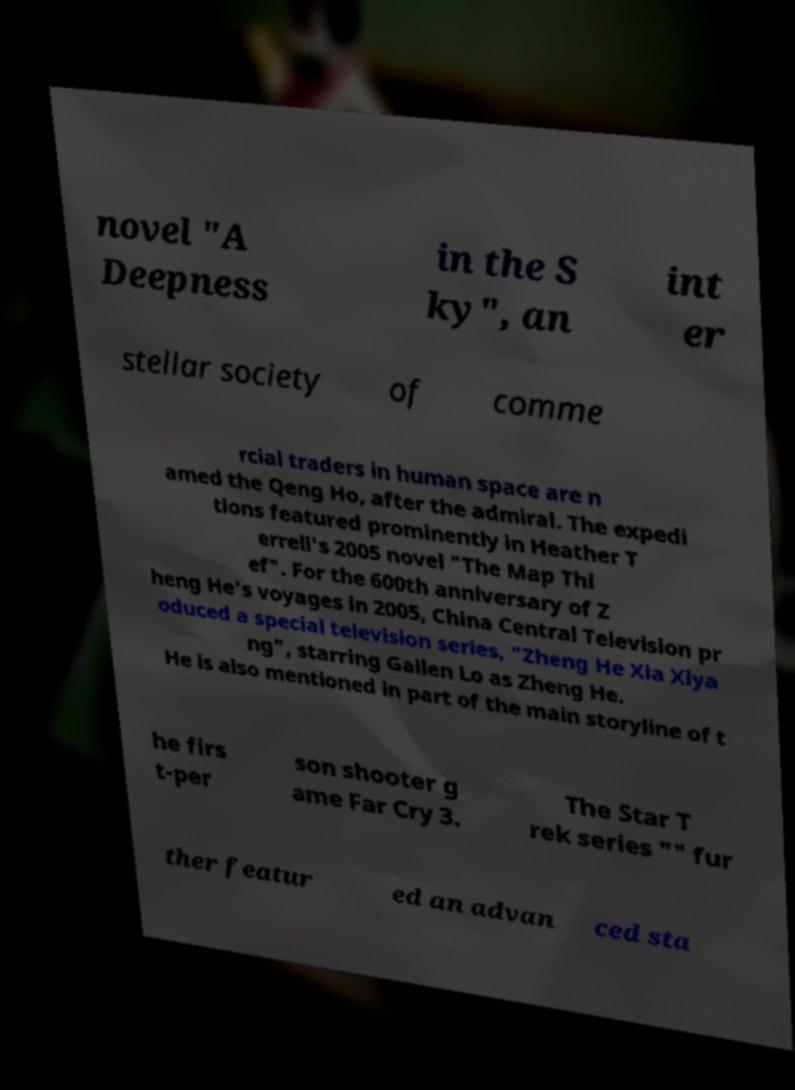Could you assist in decoding the text presented in this image and type it out clearly? novel "A Deepness in the S ky", an int er stellar society of comme rcial traders in human space are n amed the Qeng Ho, after the admiral. The expedi tions featured prominently in Heather T errell's 2005 novel "The Map Thi ef". For the 600th anniversary of Z heng He's voyages in 2005, China Central Television pr oduced a special television series, "Zheng He Xia Xiya ng", starring Gallen Lo as Zheng He. He is also mentioned in part of the main storyline of t he firs t-per son shooter g ame Far Cry 3. The Star T rek series "" fur ther featur ed an advan ced sta 